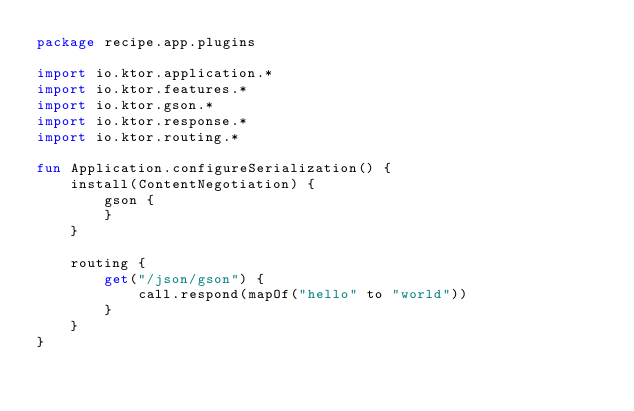Convert code to text. <code><loc_0><loc_0><loc_500><loc_500><_Kotlin_>package recipe.app.plugins

import io.ktor.application.*
import io.ktor.features.*
import io.ktor.gson.*
import io.ktor.response.*
import io.ktor.routing.*

fun Application.configureSerialization() {
    install(ContentNegotiation) {
        gson {
        }
    }

    routing {
        get("/json/gson") {
            call.respond(mapOf("hello" to "world"))
        }
    }
}
</code> 